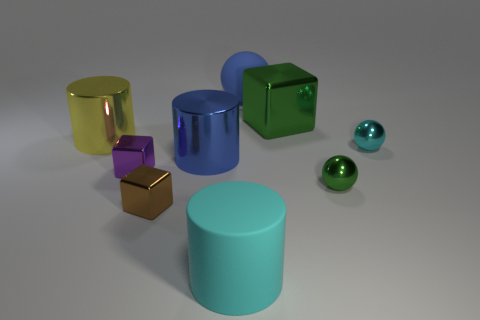Subtract all cylinders. How many objects are left? 6 Subtract 0 gray cylinders. How many objects are left? 9 Subtract all gray matte things. Subtract all big cyan cylinders. How many objects are left? 8 Add 7 big blue shiny cylinders. How many big blue shiny cylinders are left? 8 Add 4 tiny purple shiny spheres. How many tiny purple shiny spheres exist? 4 